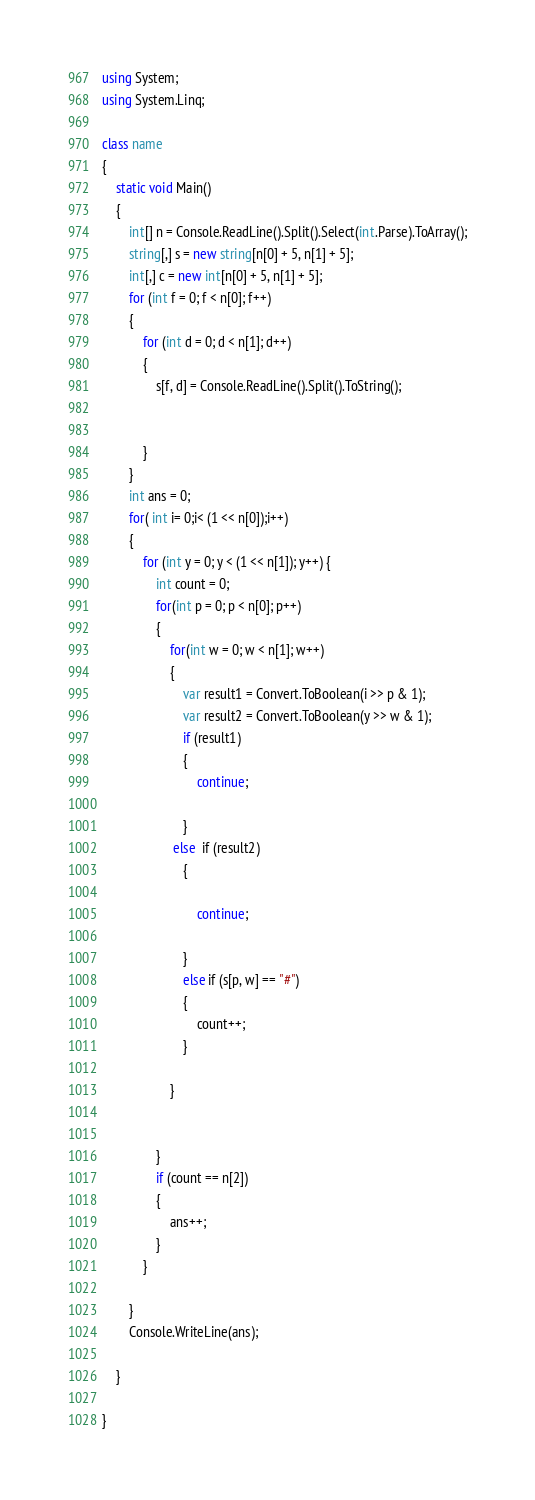Convert code to text. <code><loc_0><loc_0><loc_500><loc_500><_C#_>using System;
using System.Linq;

class name
{
    static void Main()
    {
        int[] n = Console.ReadLine().Split().Select(int.Parse).ToArray();
        string[,] s = new string[n[0] + 5, n[1] + 5];
        int[,] c = new int[n[0] + 5, n[1] + 5];
        for (int f = 0; f < n[0]; f++)
        {
            for (int d = 0; d < n[1]; d++)
            {
                s[f, d] = Console.ReadLine().Split().ToString();
               
              
            }
        }
        int ans = 0;
        for( int i= 0;i< (1 << n[0]);i++)
        {
            for (int y = 0; y < (1 << n[1]); y++) {
                int count = 0;
                for(int p = 0; p < n[0]; p++)
                {
                    for(int w = 0; w < n[1]; w++)
                    {
                        var result1 = Convert.ToBoolean(i >> p & 1);
                        var result2 = Convert.ToBoolean(y >> w & 1);
                        if (result1)
                        {
                            continue;

                        }
                     else  if (result2)
                        {

                            continue;

                        }
                        else if (s[p, w] == "#")
                        {
                            count++;
                        }

                    }


                }
                if (count == n[2])
                {
                    ans++;
                }
            }

        }
        Console.WriteLine(ans);

    }

}</code> 